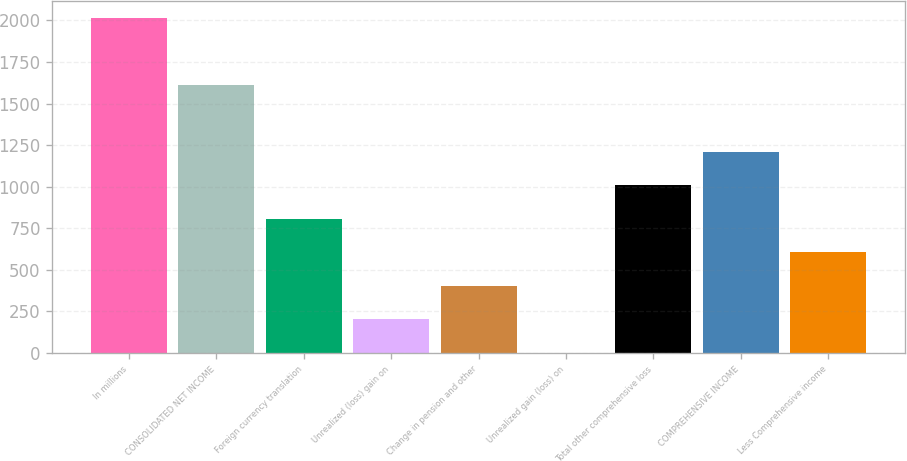<chart> <loc_0><loc_0><loc_500><loc_500><bar_chart><fcel>In millions<fcel>CONSOLIDATED NET INCOME<fcel>Foreign currency translation<fcel>Unrealized (loss) gain on<fcel>Change in pension and other<fcel>Unrealized gain (loss) on<fcel>Total other comprehensive loss<fcel>COMPREHENSIVE INCOME<fcel>Less Comprehensive income<nl><fcel>2016<fcel>1613<fcel>807<fcel>202.5<fcel>404<fcel>1<fcel>1008.5<fcel>1210<fcel>605.5<nl></chart> 